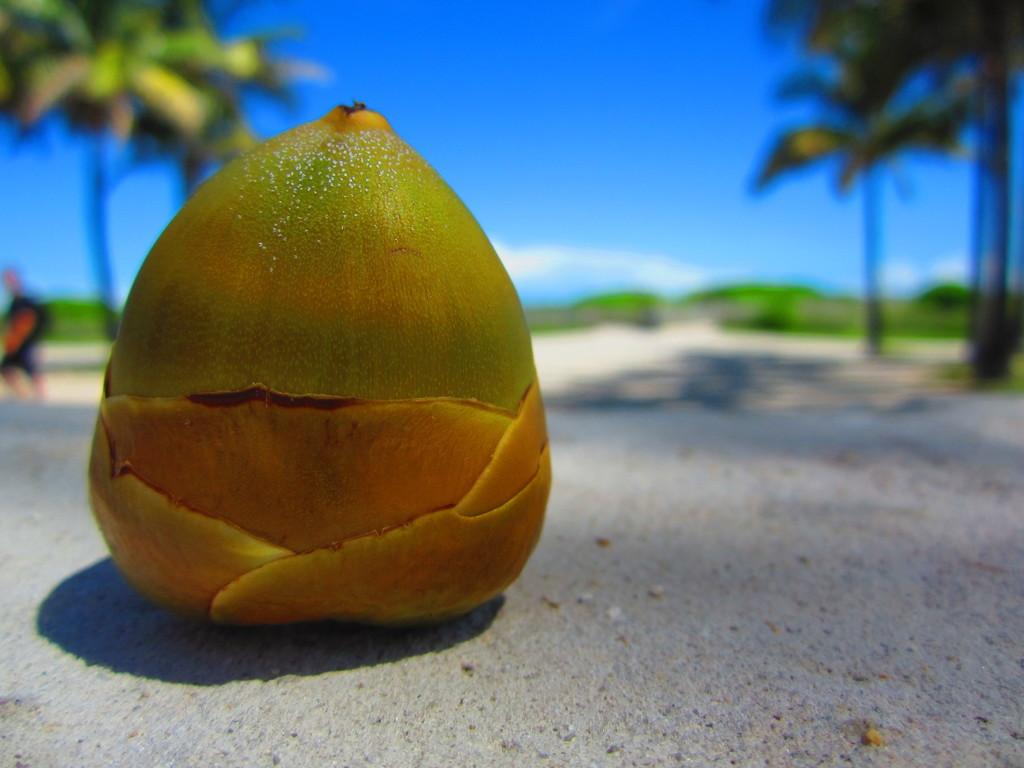What is the main subject of the image? There is a little coconut in the image. What can be seen on either side of the coconut? There are trees on either side of the image. What is visible at the top of the image? The sky is visible at the top of the image. What type of tooth is visible in the image? There is no tooth present in the image; it features a little coconut and trees. Who is the representative standing next to the coconut in the image? There is no representative present in the image; it only features a little coconut, trees, and the sky. 